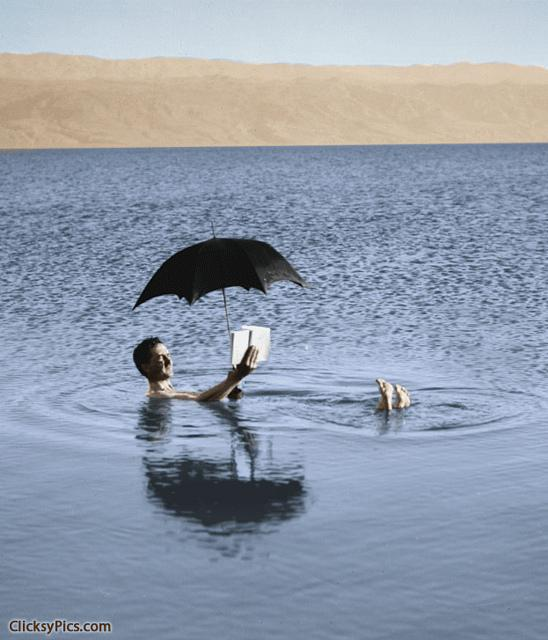Why is the man holding an umbrella?

Choices:
A) to swim
B) for cosplay
C) to dance
D) for shade for shade 